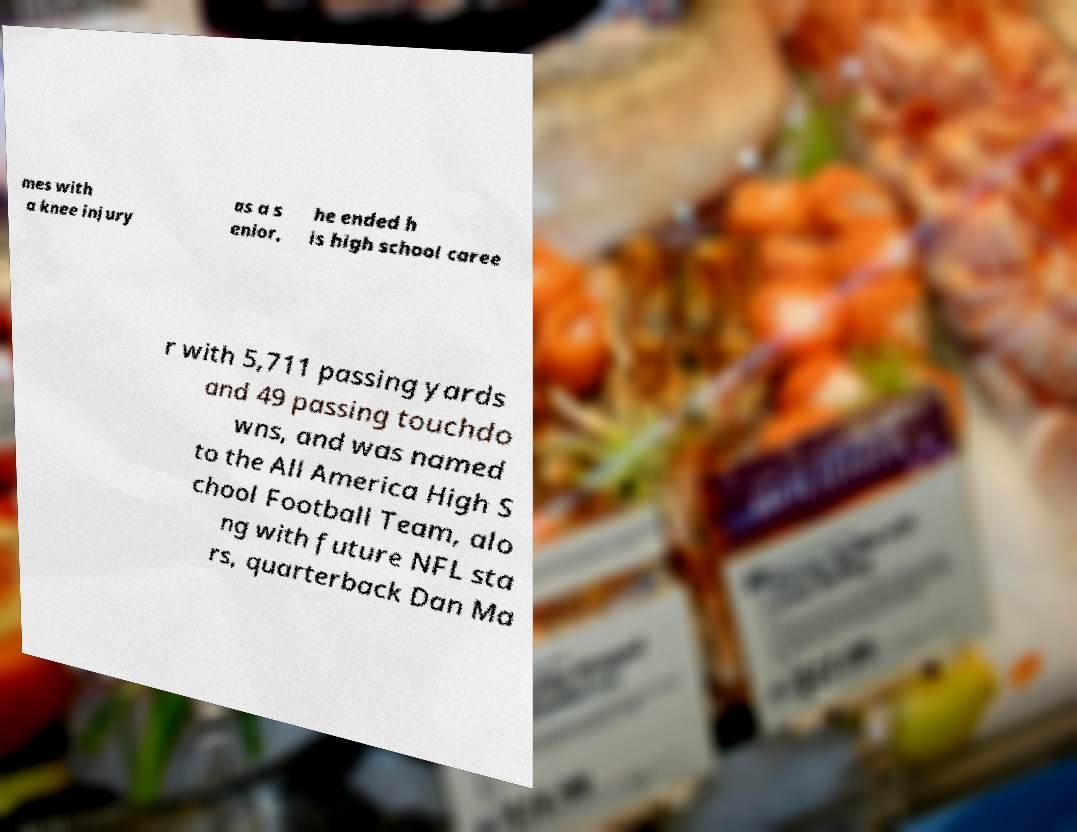Please identify and transcribe the text found in this image. mes with a knee injury as a s enior, he ended h is high school caree r with 5,711 passing yards and 49 passing touchdo wns, and was named to the All America High S chool Football Team, alo ng with future NFL sta rs, quarterback Dan Ma 